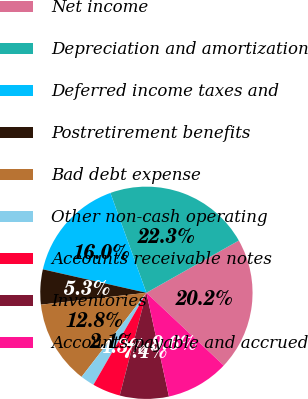<chart> <loc_0><loc_0><loc_500><loc_500><pie_chart><fcel>Net income<fcel>Depreciation and amortization<fcel>Deferred income taxes and<fcel>Postretirement benefits<fcel>Bad debt expense<fcel>Other non-cash operating<fcel>Accounts receivable notes<fcel>Inventories<fcel>Accounts payable and accrued<nl><fcel>20.2%<fcel>22.32%<fcel>15.95%<fcel>5.33%<fcel>12.76%<fcel>2.14%<fcel>4.27%<fcel>7.45%<fcel>9.58%<nl></chart> 